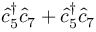Convert formula to latex. <formula><loc_0><loc_0><loc_500><loc_500>\hat { c } _ { 5 } ^ { \dagger } \hat { c } _ { 7 } + \hat { c } _ { 5 } ^ { \dagger } \hat { c } _ { 7 }</formula> 